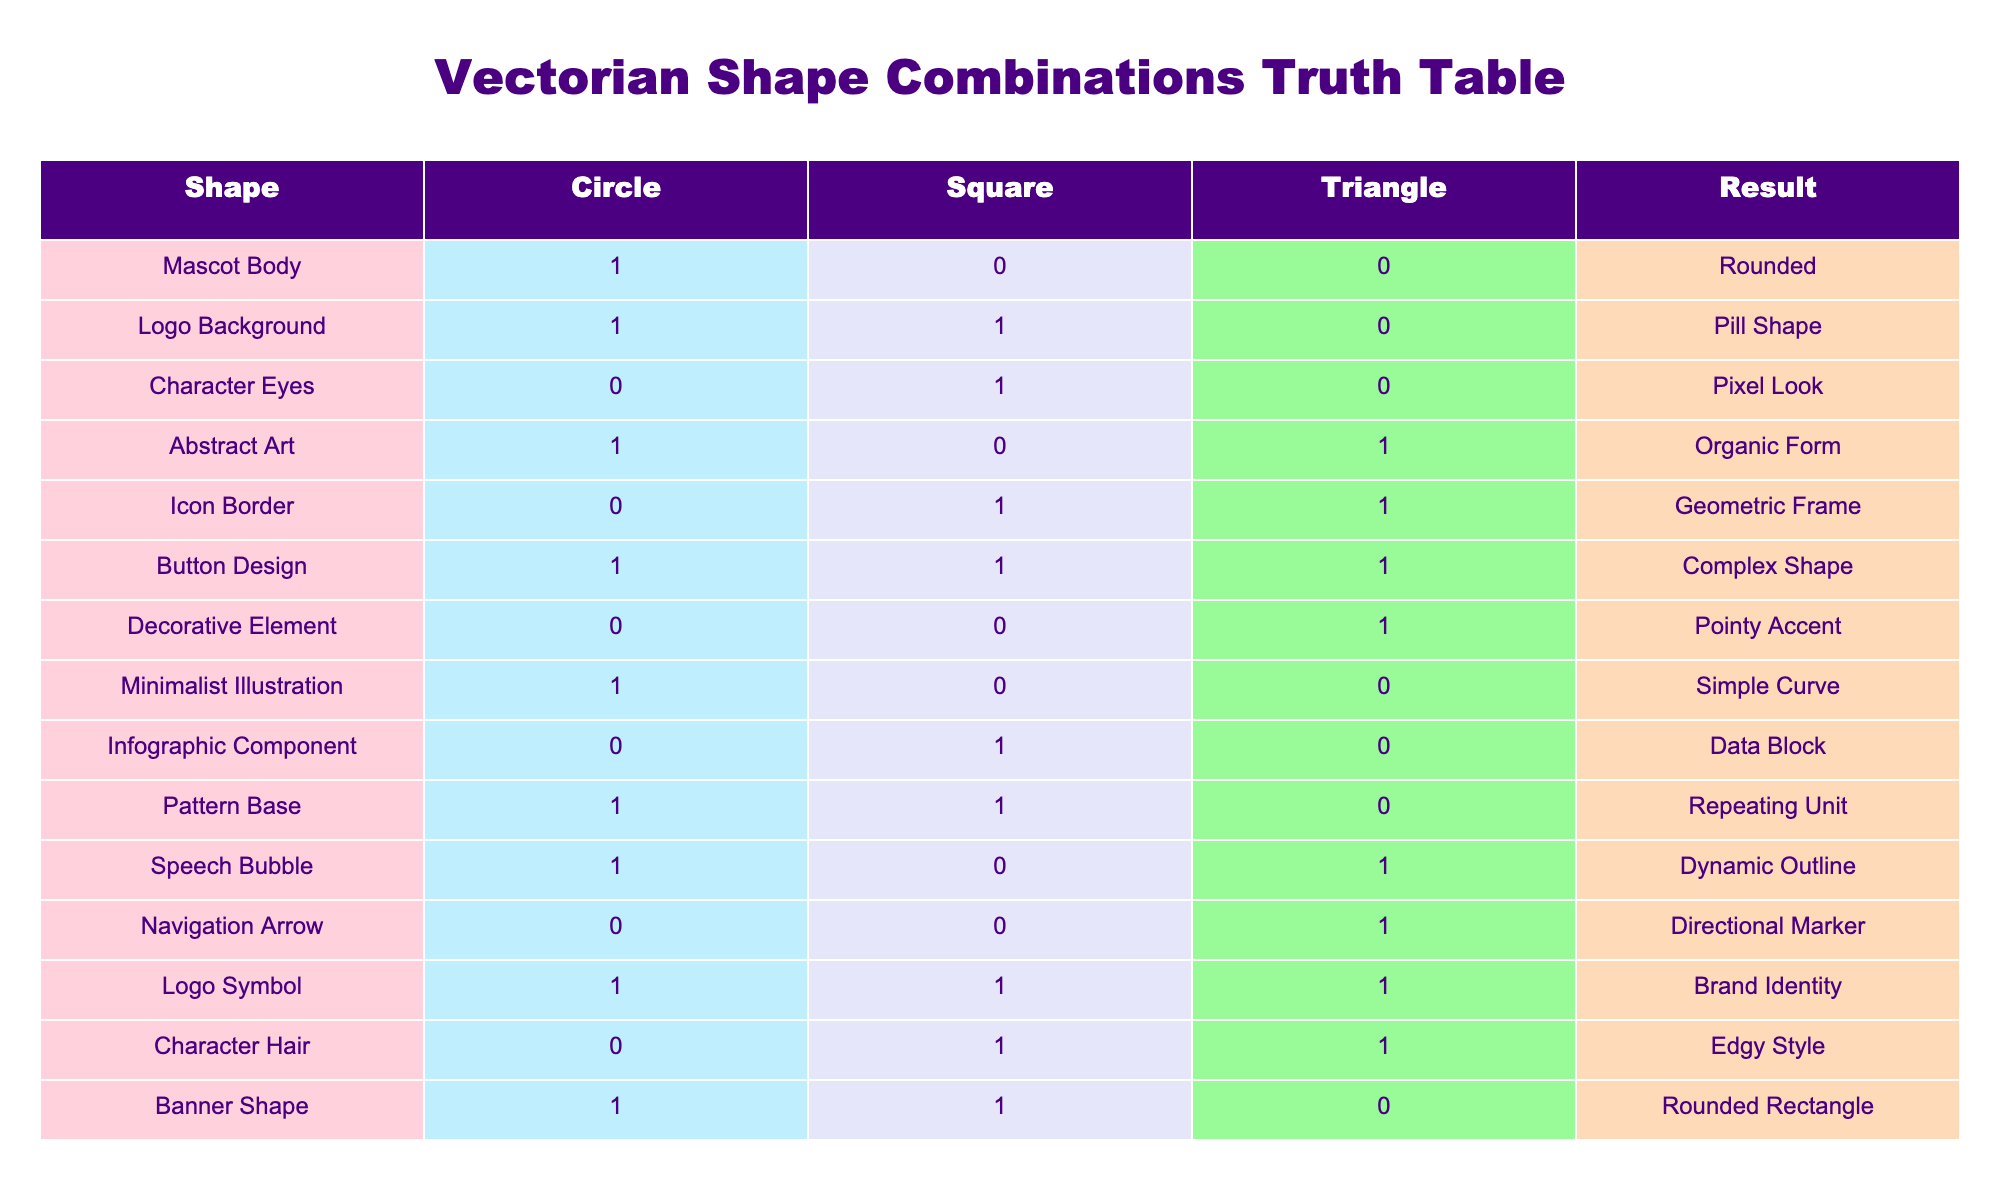What shape results from the combination of a Triangle and a Circle? Referring to the table, we can see that when both Triangle (0) and Circle (1) are selected together, the resulting shape is "Rounded."
Answer: Rounded How many designs include a Square in their combination? By looking at the table, we count the rows where the Square value is 1. The relevant designs are: "Character Eyes," "Icon Border," "Logo Background," "Character Hair," "Banner Shape," and "Logo Symbol," totaling 5 designs.
Answer: 5 Is there any design that uniquely combines a Circle and a Triangle without a Square? The only design that fits this criterion is "Speech Bubble," which has Circle (1) and Triangle (1), but Square (0), confirming that it is indeed a unique combination.
Answer: Yes What is the result of combining all three shapes: Circle, Square, and Triangle? Referring to the table, when all three shapes (1, 1, 1) are combined, the resulting shape is "Complex Shape," as seen in the "Button Design" row.
Answer: Complex Shape For which shapes is the "Data Block" result obtained, and how is it formed? "Data Block" is obtained when Circle (0), Square (1), and Triangle (0) are combined based on the "Infographic Component" row. This means it's formed by selecting only a Square shape, leading to a Data Block.
Answer: Square What shapes yield an "Organic Form" and how many such combinations exist? The "Organic Form" is produced by combining Circle (1) and Triangle (1) while excluding Square, shown in the "Abstract Art" row. This combination exists only once in the table.
Answer: 1 Do any designs feature a Circle but lack both a Square and a Triangle? Upon examination, the "Minimalist Illustration" has Circle (1), Square (0), and Triangle (0). Thus, it does confirm that such a design exists.
Answer: Yes What shapes lead to a "Geometric Frame" result, and how is it characterized? The "Icon Border" row indicates that Circle (0), Square (1), and Triangle (1) produce the "Geometric Frame," characterizing it as a frame feature surrounding shapes based on the selected values.
Answer: Square and Triangle 